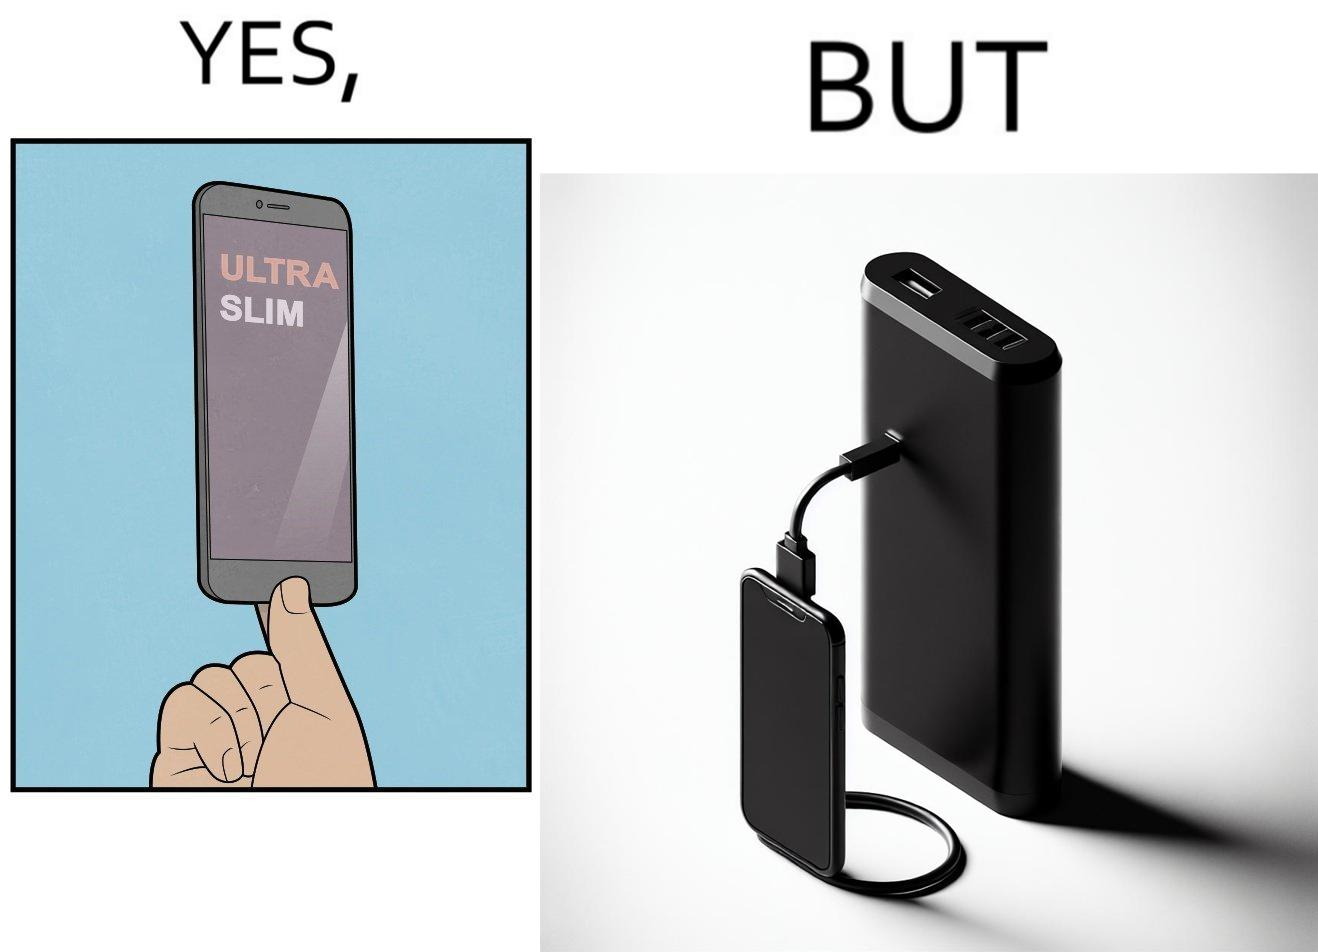Is there satirical content in this image? Yes, this image is satirical. 